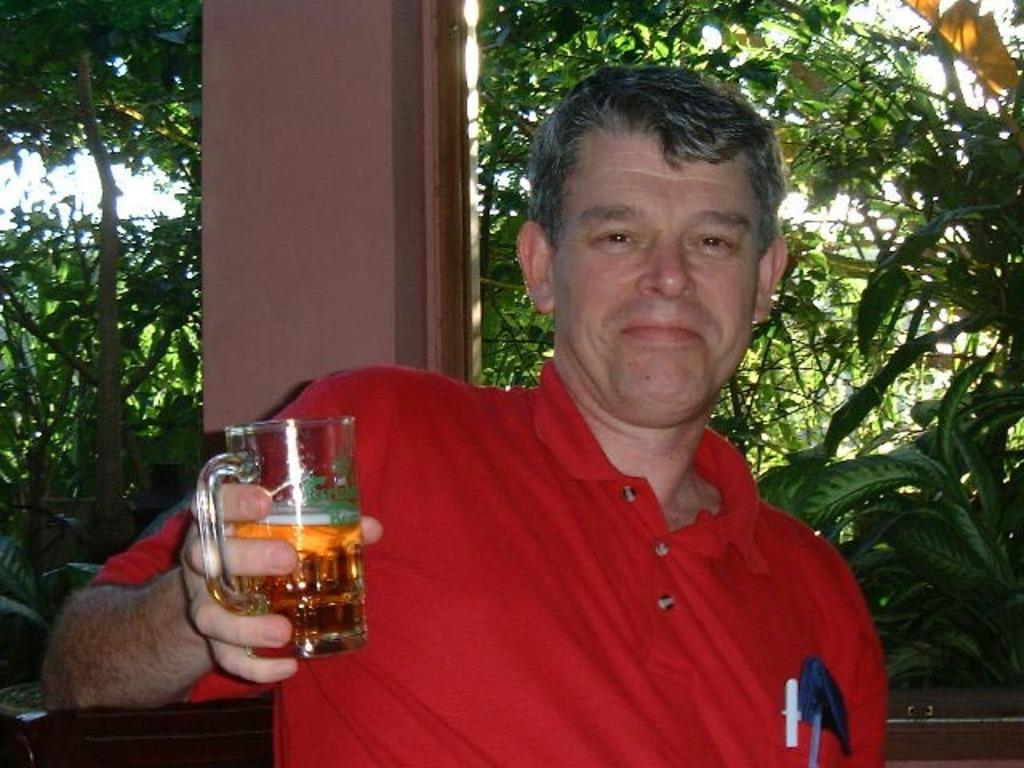Who is present in the image? There is a person in the image. What is the person holding in the image? The person is holding a wine glass. What can be seen in the background of the image? There are planets and a pillar visible in the background of the image. Can you see the coach in the image? There is no coach present in the image. Are the people in the image kissing? The image only shows a person holding a wine glass, and there is no indication of any kissing. 